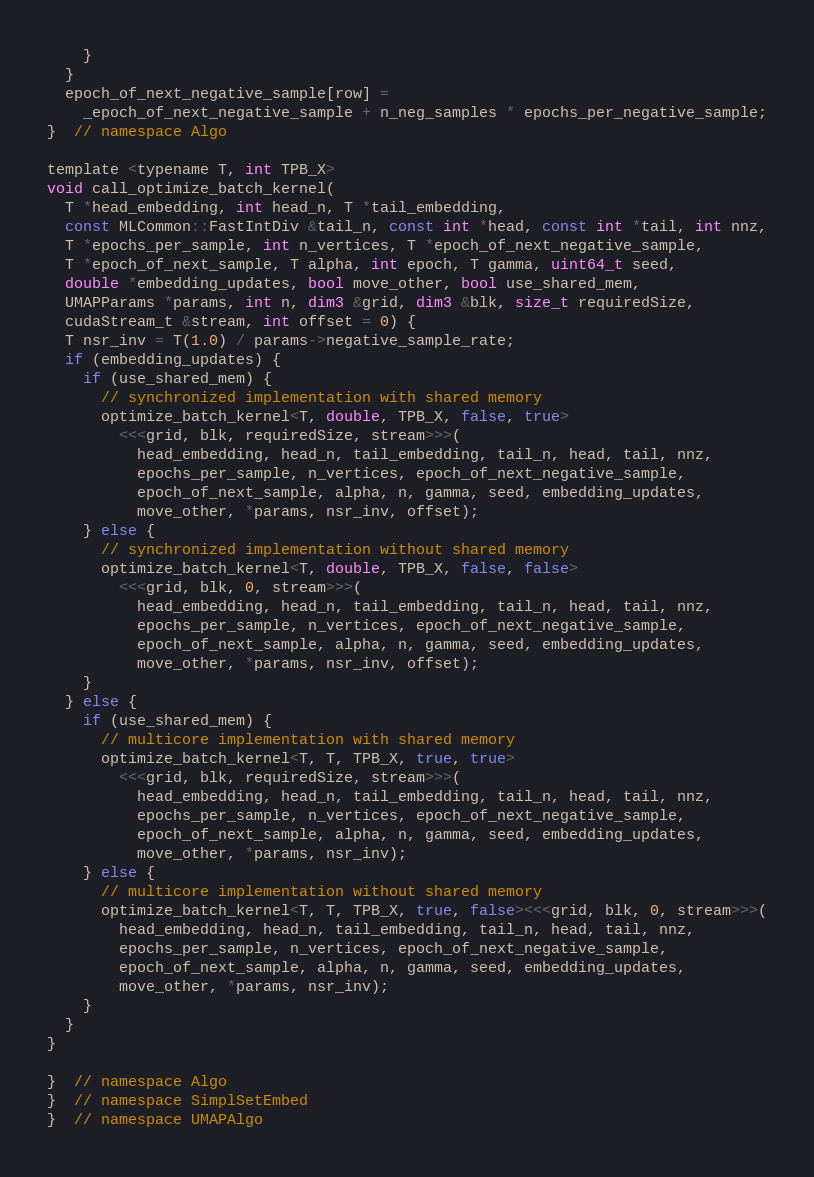<code> <loc_0><loc_0><loc_500><loc_500><_Cuda_>    }
  }
  epoch_of_next_negative_sample[row] =
    _epoch_of_next_negative_sample + n_neg_samples * epochs_per_negative_sample;
}  // namespace Algo

template <typename T, int TPB_X>
void call_optimize_batch_kernel(
  T *head_embedding, int head_n, T *tail_embedding,
  const MLCommon::FastIntDiv &tail_n, const int *head, const int *tail, int nnz,
  T *epochs_per_sample, int n_vertices, T *epoch_of_next_negative_sample,
  T *epoch_of_next_sample, T alpha, int epoch, T gamma, uint64_t seed,
  double *embedding_updates, bool move_other, bool use_shared_mem,
  UMAPParams *params, int n, dim3 &grid, dim3 &blk, size_t requiredSize,
  cudaStream_t &stream, int offset = 0) {
  T nsr_inv = T(1.0) / params->negative_sample_rate;
  if (embedding_updates) {
    if (use_shared_mem) {
      // synchronized implementation with shared memory
      optimize_batch_kernel<T, double, TPB_X, false, true>
        <<<grid, blk, requiredSize, stream>>>(
          head_embedding, head_n, tail_embedding, tail_n, head, tail, nnz,
          epochs_per_sample, n_vertices, epoch_of_next_negative_sample,
          epoch_of_next_sample, alpha, n, gamma, seed, embedding_updates,
          move_other, *params, nsr_inv, offset);
    } else {
      // synchronized implementation without shared memory
      optimize_batch_kernel<T, double, TPB_X, false, false>
        <<<grid, blk, 0, stream>>>(
          head_embedding, head_n, tail_embedding, tail_n, head, tail, nnz,
          epochs_per_sample, n_vertices, epoch_of_next_negative_sample,
          epoch_of_next_sample, alpha, n, gamma, seed, embedding_updates,
          move_other, *params, nsr_inv, offset);
    }
  } else {
    if (use_shared_mem) {
      // multicore implementation with shared memory
      optimize_batch_kernel<T, T, TPB_X, true, true>
        <<<grid, blk, requiredSize, stream>>>(
          head_embedding, head_n, tail_embedding, tail_n, head, tail, nnz,
          epochs_per_sample, n_vertices, epoch_of_next_negative_sample,
          epoch_of_next_sample, alpha, n, gamma, seed, embedding_updates,
          move_other, *params, nsr_inv);
    } else {
      // multicore implementation without shared memory
      optimize_batch_kernel<T, T, TPB_X, true, false><<<grid, blk, 0, stream>>>(
        head_embedding, head_n, tail_embedding, tail_n, head, tail, nnz,
        epochs_per_sample, n_vertices, epoch_of_next_negative_sample,
        epoch_of_next_sample, alpha, n, gamma, seed, embedding_updates,
        move_other, *params, nsr_inv);
    }
  }
}

}  // namespace Algo
}  // namespace SimplSetEmbed
}  // namespace UMAPAlgo
</code> 